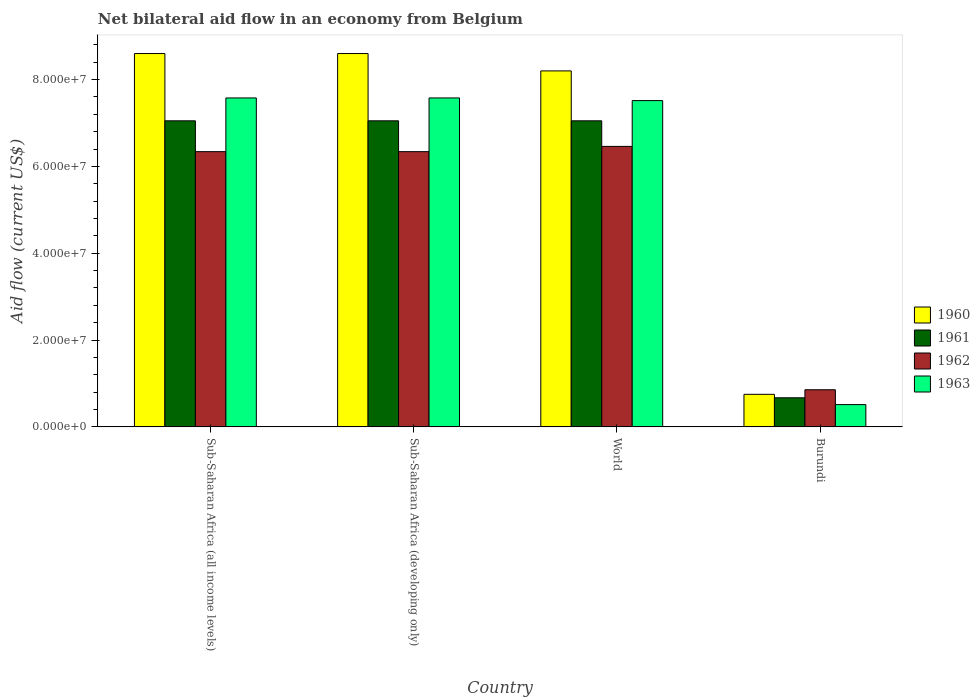How many different coloured bars are there?
Offer a terse response. 4. How many groups of bars are there?
Your response must be concise. 4. How many bars are there on the 1st tick from the left?
Your answer should be very brief. 4. What is the label of the 2nd group of bars from the left?
Provide a succinct answer. Sub-Saharan Africa (developing only). In how many cases, is the number of bars for a given country not equal to the number of legend labels?
Provide a short and direct response. 0. What is the net bilateral aid flow in 1960 in Sub-Saharan Africa (all income levels)?
Give a very brief answer. 8.60e+07. Across all countries, what is the maximum net bilateral aid flow in 1962?
Your response must be concise. 6.46e+07. Across all countries, what is the minimum net bilateral aid flow in 1962?
Offer a terse response. 8.55e+06. In which country was the net bilateral aid flow in 1961 minimum?
Offer a very short reply. Burundi. What is the total net bilateral aid flow in 1961 in the graph?
Provide a succinct answer. 2.18e+08. What is the difference between the net bilateral aid flow in 1963 in Burundi and that in Sub-Saharan Africa (developing only)?
Offer a terse response. -7.06e+07. What is the difference between the net bilateral aid flow in 1963 in Sub-Saharan Africa (all income levels) and the net bilateral aid flow in 1962 in World?
Offer a very short reply. 1.12e+07. What is the average net bilateral aid flow in 1962 per country?
Provide a succinct answer. 5.00e+07. What is the difference between the net bilateral aid flow of/in 1963 and net bilateral aid flow of/in 1961 in World?
Provide a succinct answer. 4.66e+06. In how many countries, is the net bilateral aid flow in 1960 greater than 16000000 US$?
Ensure brevity in your answer.  3. Is the net bilateral aid flow in 1962 in Burundi less than that in World?
Provide a succinct answer. Yes. Is the difference between the net bilateral aid flow in 1963 in Sub-Saharan Africa (all income levels) and Sub-Saharan Africa (developing only) greater than the difference between the net bilateral aid flow in 1961 in Sub-Saharan Africa (all income levels) and Sub-Saharan Africa (developing only)?
Provide a short and direct response. No. What is the difference between the highest and the second highest net bilateral aid flow in 1960?
Provide a succinct answer. 4.00e+06. What is the difference between the highest and the lowest net bilateral aid flow in 1962?
Your answer should be compact. 5.61e+07. In how many countries, is the net bilateral aid flow in 1961 greater than the average net bilateral aid flow in 1961 taken over all countries?
Offer a terse response. 3. Is the sum of the net bilateral aid flow in 1963 in Burundi and World greater than the maximum net bilateral aid flow in 1962 across all countries?
Offer a very short reply. Yes. Is it the case that in every country, the sum of the net bilateral aid flow in 1962 and net bilateral aid flow in 1960 is greater than the sum of net bilateral aid flow in 1963 and net bilateral aid flow in 1961?
Give a very brief answer. No. What does the 2nd bar from the right in World represents?
Give a very brief answer. 1962. Are all the bars in the graph horizontal?
Provide a short and direct response. No. How many countries are there in the graph?
Your response must be concise. 4. Where does the legend appear in the graph?
Provide a succinct answer. Center right. How many legend labels are there?
Your answer should be compact. 4. How are the legend labels stacked?
Your response must be concise. Vertical. What is the title of the graph?
Provide a succinct answer. Net bilateral aid flow in an economy from Belgium. What is the label or title of the Y-axis?
Give a very brief answer. Aid flow (current US$). What is the Aid flow (current US$) in 1960 in Sub-Saharan Africa (all income levels)?
Offer a terse response. 8.60e+07. What is the Aid flow (current US$) of 1961 in Sub-Saharan Africa (all income levels)?
Your response must be concise. 7.05e+07. What is the Aid flow (current US$) of 1962 in Sub-Saharan Africa (all income levels)?
Give a very brief answer. 6.34e+07. What is the Aid flow (current US$) of 1963 in Sub-Saharan Africa (all income levels)?
Ensure brevity in your answer.  7.58e+07. What is the Aid flow (current US$) in 1960 in Sub-Saharan Africa (developing only)?
Your answer should be compact. 8.60e+07. What is the Aid flow (current US$) in 1961 in Sub-Saharan Africa (developing only)?
Your answer should be compact. 7.05e+07. What is the Aid flow (current US$) in 1962 in Sub-Saharan Africa (developing only)?
Provide a short and direct response. 6.34e+07. What is the Aid flow (current US$) of 1963 in Sub-Saharan Africa (developing only)?
Offer a terse response. 7.58e+07. What is the Aid flow (current US$) in 1960 in World?
Make the answer very short. 8.20e+07. What is the Aid flow (current US$) in 1961 in World?
Your response must be concise. 7.05e+07. What is the Aid flow (current US$) of 1962 in World?
Keep it short and to the point. 6.46e+07. What is the Aid flow (current US$) of 1963 in World?
Your answer should be very brief. 7.52e+07. What is the Aid flow (current US$) of 1960 in Burundi?
Your answer should be very brief. 7.50e+06. What is the Aid flow (current US$) of 1961 in Burundi?
Ensure brevity in your answer.  6.70e+06. What is the Aid flow (current US$) of 1962 in Burundi?
Provide a succinct answer. 8.55e+06. What is the Aid flow (current US$) in 1963 in Burundi?
Ensure brevity in your answer.  5.13e+06. Across all countries, what is the maximum Aid flow (current US$) of 1960?
Make the answer very short. 8.60e+07. Across all countries, what is the maximum Aid flow (current US$) of 1961?
Offer a very short reply. 7.05e+07. Across all countries, what is the maximum Aid flow (current US$) of 1962?
Provide a succinct answer. 6.46e+07. Across all countries, what is the maximum Aid flow (current US$) of 1963?
Offer a very short reply. 7.58e+07. Across all countries, what is the minimum Aid flow (current US$) in 1960?
Provide a short and direct response. 7.50e+06. Across all countries, what is the minimum Aid flow (current US$) in 1961?
Your answer should be compact. 6.70e+06. Across all countries, what is the minimum Aid flow (current US$) in 1962?
Provide a short and direct response. 8.55e+06. Across all countries, what is the minimum Aid flow (current US$) in 1963?
Provide a succinct answer. 5.13e+06. What is the total Aid flow (current US$) in 1960 in the graph?
Your answer should be compact. 2.62e+08. What is the total Aid flow (current US$) of 1961 in the graph?
Your response must be concise. 2.18e+08. What is the total Aid flow (current US$) in 1962 in the graph?
Offer a very short reply. 2.00e+08. What is the total Aid flow (current US$) of 1963 in the graph?
Provide a short and direct response. 2.32e+08. What is the difference between the Aid flow (current US$) in 1960 in Sub-Saharan Africa (all income levels) and that in World?
Ensure brevity in your answer.  4.00e+06. What is the difference between the Aid flow (current US$) in 1962 in Sub-Saharan Africa (all income levels) and that in World?
Your answer should be very brief. -1.21e+06. What is the difference between the Aid flow (current US$) of 1963 in Sub-Saharan Africa (all income levels) and that in World?
Keep it short and to the point. 6.10e+05. What is the difference between the Aid flow (current US$) of 1960 in Sub-Saharan Africa (all income levels) and that in Burundi?
Provide a succinct answer. 7.85e+07. What is the difference between the Aid flow (current US$) of 1961 in Sub-Saharan Africa (all income levels) and that in Burundi?
Make the answer very short. 6.38e+07. What is the difference between the Aid flow (current US$) of 1962 in Sub-Saharan Africa (all income levels) and that in Burundi?
Your answer should be compact. 5.48e+07. What is the difference between the Aid flow (current US$) in 1963 in Sub-Saharan Africa (all income levels) and that in Burundi?
Ensure brevity in your answer.  7.06e+07. What is the difference between the Aid flow (current US$) of 1961 in Sub-Saharan Africa (developing only) and that in World?
Your answer should be very brief. 0. What is the difference between the Aid flow (current US$) of 1962 in Sub-Saharan Africa (developing only) and that in World?
Give a very brief answer. -1.21e+06. What is the difference between the Aid flow (current US$) of 1963 in Sub-Saharan Africa (developing only) and that in World?
Your response must be concise. 6.10e+05. What is the difference between the Aid flow (current US$) of 1960 in Sub-Saharan Africa (developing only) and that in Burundi?
Provide a short and direct response. 7.85e+07. What is the difference between the Aid flow (current US$) in 1961 in Sub-Saharan Africa (developing only) and that in Burundi?
Make the answer very short. 6.38e+07. What is the difference between the Aid flow (current US$) of 1962 in Sub-Saharan Africa (developing only) and that in Burundi?
Ensure brevity in your answer.  5.48e+07. What is the difference between the Aid flow (current US$) of 1963 in Sub-Saharan Africa (developing only) and that in Burundi?
Your response must be concise. 7.06e+07. What is the difference between the Aid flow (current US$) in 1960 in World and that in Burundi?
Your answer should be very brief. 7.45e+07. What is the difference between the Aid flow (current US$) of 1961 in World and that in Burundi?
Offer a terse response. 6.38e+07. What is the difference between the Aid flow (current US$) in 1962 in World and that in Burundi?
Offer a terse response. 5.61e+07. What is the difference between the Aid flow (current US$) of 1963 in World and that in Burundi?
Offer a very short reply. 7.00e+07. What is the difference between the Aid flow (current US$) of 1960 in Sub-Saharan Africa (all income levels) and the Aid flow (current US$) of 1961 in Sub-Saharan Africa (developing only)?
Offer a very short reply. 1.55e+07. What is the difference between the Aid flow (current US$) of 1960 in Sub-Saharan Africa (all income levels) and the Aid flow (current US$) of 1962 in Sub-Saharan Africa (developing only)?
Offer a terse response. 2.26e+07. What is the difference between the Aid flow (current US$) of 1960 in Sub-Saharan Africa (all income levels) and the Aid flow (current US$) of 1963 in Sub-Saharan Africa (developing only)?
Offer a very short reply. 1.02e+07. What is the difference between the Aid flow (current US$) of 1961 in Sub-Saharan Africa (all income levels) and the Aid flow (current US$) of 1962 in Sub-Saharan Africa (developing only)?
Your answer should be compact. 7.10e+06. What is the difference between the Aid flow (current US$) of 1961 in Sub-Saharan Africa (all income levels) and the Aid flow (current US$) of 1963 in Sub-Saharan Africa (developing only)?
Give a very brief answer. -5.27e+06. What is the difference between the Aid flow (current US$) in 1962 in Sub-Saharan Africa (all income levels) and the Aid flow (current US$) in 1963 in Sub-Saharan Africa (developing only)?
Your response must be concise. -1.24e+07. What is the difference between the Aid flow (current US$) in 1960 in Sub-Saharan Africa (all income levels) and the Aid flow (current US$) in 1961 in World?
Offer a very short reply. 1.55e+07. What is the difference between the Aid flow (current US$) of 1960 in Sub-Saharan Africa (all income levels) and the Aid flow (current US$) of 1962 in World?
Your response must be concise. 2.14e+07. What is the difference between the Aid flow (current US$) in 1960 in Sub-Saharan Africa (all income levels) and the Aid flow (current US$) in 1963 in World?
Provide a short and direct response. 1.08e+07. What is the difference between the Aid flow (current US$) in 1961 in Sub-Saharan Africa (all income levels) and the Aid flow (current US$) in 1962 in World?
Provide a succinct answer. 5.89e+06. What is the difference between the Aid flow (current US$) in 1961 in Sub-Saharan Africa (all income levels) and the Aid flow (current US$) in 1963 in World?
Your response must be concise. -4.66e+06. What is the difference between the Aid flow (current US$) of 1962 in Sub-Saharan Africa (all income levels) and the Aid flow (current US$) of 1963 in World?
Your answer should be compact. -1.18e+07. What is the difference between the Aid flow (current US$) of 1960 in Sub-Saharan Africa (all income levels) and the Aid flow (current US$) of 1961 in Burundi?
Ensure brevity in your answer.  7.93e+07. What is the difference between the Aid flow (current US$) of 1960 in Sub-Saharan Africa (all income levels) and the Aid flow (current US$) of 1962 in Burundi?
Give a very brief answer. 7.74e+07. What is the difference between the Aid flow (current US$) of 1960 in Sub-Saharan Africa (all income levels) and the Aid flow (current US$) of 1963 in Burundi?
Your answer should be very brief. 8.09e+07. What is the difference between the Aid flow (current US$) in 1961 in Sub-Saharan Africa (all income levels) and the Aid flow (current US$) in 1962 in Burundi?
Offer a very short reply. 6.20e+07. What is the difference between the Aid flow (current US$) of 1961 in Sub-Saharan Africa (all income levels) and the Aid flow (current US$) of 1963 in Burundi?
Ensure brevity in your answer.  6.54e+07. What is the difference between the Aid flow (current US$) of 1962 in Sub-Saharan Africa (all income levels) and the Aid flow (current US$) of 1963 in Burundi?
Make the answer very short. 5.83e+07. What is the difference between the Aid flow (current US$) in 1960 in Sub-Saharan Africa (developing only) and the Aid flow (current US$) in 1961 in World?
Your response must be concise. 1.55e+07. What is the difference between the Aid flow (current US$) in 1960 in Sub-Saharan Africa (developing only) and the Aid flow (current US$) in 1962 in World?
Offer a terse response. 2.14e+07. What is the difference between the Aid flow (current US$) in 1960 in Sub-Saharan Africa (developing only) and the Aid flow (current US$) in 1963 in World?
Your response must be concise. 1.08e+07. What is the difference between the Aid flow (current US$) of 1961 in Sub-Saharan Africa (developing only) and the Aid flow (current US$) of 1962 in World?
Ensure brevity in your answer.  5.89e+06. What is the difference between the Aid flow (current US$) in 1961 in Sub-Saharan Africa (developing only) and the Aid flow (current US$) in 1963 in World?
Give a very brief answer. -4.66e+06. What is the difference between the Aid flow (current US$) of 1962 in Sub-Saharan Africa (developing only) and the Aid flow (current US$) of 1963 in World?
Your answer should be very brief. -1.18e+07. What is the difference between the Aid flow (current US$) of 1960 in Sub-Saharan Africa (developing only) and the Aid flow (current US$) of 1961 in Burundi?
Your response must be concise. 7.93e+07. What is the difference between the Aid flow (current US$) in 1960 in Sub-Saharan Africa (developing only) and the Aid flow (current US$) in 1962 in Burundi?
Offer a terse response. 7.74e+07. What is the difference between the Aid flow (current US$) of 1960 in Sub-Saharan Africa (developing only) and the Aid flow (current US$) of 1963 in Burundi?
Offer a very short reply. 8.09e+07. What is the difference between the Aid flow (current US$) in 1961 in Sub-Saharan Africa (developing only) and the Aid flow (current US$) in 1962 in Burundi?
Give a very brief answer. 6.20e+07. What is the difference between the Aid flow (current US$) of 1961 in Sub-Saharan Africa (developing only) and the Aid flow (current US$) of 1963 in Burundi?
Offer a very short reply. 6.54e+07. What is the difference between the Aid flow (current US$) of 1962 in Sub-Saharan Africa (developing only) and the Aid flow (current US$) of 1963 in Burundi?
Keep it short and to the point. 5.83e+07. What is the difference between the Aid flow (current US$) in 1960 in World and the Aid flow (current US$) in 1961 in Burundi?
Offer a terse response. 7.53e+07. What is the difference between the Aid flow (current US$) of 1960 in World and the Aid flow (current US$) of 1962 in Burundi?
Your answer should be very brief. 7.34e+07. What is the difference between the Aid flow (current US$) of 1960 in World and the Aid flow (current US$) of 1963 in Burundi?
Provide a succinct answer. 7.69e+07. What is the difference between the Aid flow (current US$) in 1961 in World and the Aid flow (current US$) in 1962 in Burundi?
Your answer should be very brief. 6.20e+07. What is the difference between the Aid flow (current US$) of 1961 in World and the Aid flow (current US$) of 1963 in Burundi?
Offer a very short reply. 6.54e+07. What is the difference between the Aid flow (current US$) of 1962 in World and the Aid flow (current US$) of 1963 in Burundi?
Your answer should be very brief. 5.95e+07. What is the average Aid flow (current US$) of 1960 per country?
Offer a very short reply. 6.54e+07. What is the average Aid flow (current US$) of 1961 per country?
Offer a terse response. 5.46e+07. What is the average Aid flow (current US$) of 1962 per country?
Keep it short and to the point. 5.00e+07. What is the average Aid flow (current US$) in 1963 per country?
Ensure brevity in your answer.  5.80e+07. What is the difference between the Aid flow (current US$) in 1960 and Aid flow (current US$) in 1961 in Sub-Saharan Africa (all income levels)?
Give a very brief answer. 1.55e+07. What is the difference between the Aid flow (current US$) in 1960 and Aid flow (current US$) in 1962 in Sub-Saharan Africa (all income levels)?
Offer a terse response. 2.26e+07. What is the difference between the Aid flow (current US$) in 1960 and Aid flow (current US$) in 1963 in Sub-Saharan Africa (all income levels)?
Ensure brevity in your answer.  1.02e+07. What is the difference between the Aid flow (current US$) of 1961 and Aid flow (current US$) of 1962 in Sub-Saharan Africa (all income levels)?
Provide a succinct answer. 7.10e+06. What is the difference between the Aid flow (current US$) of 1961 and Aid flow (current US$) of 1963 in Sub-Saharan Africa (all income levels)?
Your answer should be very brief. -5.27e+06. What is the difference between the Aid flow (current US$) of 1962 and Aid flow (current US$) of 1963 in Sub-Saharan Africa (all income levels)?
Make the answer very short. -1.24e+07. What is the difference between the Aid flow (current US$) in 1960 and Aid flow (current US$) in 1961 in Sub-Saharan Africa (developing only)?
Provide a succinct answer. 1.55e+07. What is the difference between the Aid flow (current US$) of 1960 and Aid flow (current US$) of 1962 in Sub-Saharan Africa (developing only)?
Keep it short and to the point. 2.26e+07. What is the difference between the Aid flow (current US$) of 1960 and Aid flow (current US$) of 1963 in Sub-Saharan Africa (developing only)?
Your answer should be compact. 1.02e+07. What is the difference between the Aid flow (current US$) in 1961 and Aid flow (current US$) in 1962 in Sub-Saharan Africa (developing only)?
Provide a succinct answer. 7.10e+06. What is the difference between the Aid flow (current US$) in 1961 and Aid flow (current US$) in 1963 in Sub-Saharan Africa (developing only)?
Your response must be concise. -5.27e+06. What is the difference between the Aid flow (current US$) in 1962 and Aid flow (current US$) in 1963 in Sub-Saharan Africa (developing only)?
Offer a terse response. -1.24e+07. What is the difference between the Aid flow (current US$) in 1960 and Aid flow (current US$) in 1961 in World?
Provide a short and direct response. 1.15e+07. What is the difference between the Aid flow (current US$) in 1960 and Aid flow (current US$) in 1962 in World?
Give a very brief answer. 1.74e+07. What is the difference between the Aid flow (current US$) of 1960 and Aid flow (current US$) of 1963 in World?
Offer a very short reply. 6.84e+06. What is the difference between the Aid flow (current US$) in 1961 and Aid flow (current US$) in 1962 in World?
Give a very brief answer. 5.89e+06. What is the difference between the Aid flow (current US$) of 1961 and Aid flow (current US$) of 1963 in World?
Make the answer very short. -4.66e+06. What is the difference between the Aid flow (current US$) in 1962 and Aid flow (current US$) in 1963 in World?
Keep it short and to the point. -1.06e+07. What is the difference between the Aid flow (current US$) in 1960 and Aid flow (current US$) in 1961 in Burundi?
Your answer should be very brief. 8.00e+05. What is the difference between the Aid flow (current US$) of 1960 and Aid flow (current US$) of 1962 in Burundi?
Give a very brief answer. -1.05e+06. What is the difference between the Aid flow (current US$) of 1960 and Aid flow (current US$) of 1963 in Burundi?
Offer a very short reply. 2.37e+06. What is the difference between the Aid flow (current US$) of 1961 and Aid flow (current US$) of 1962 in Burundi?
Give a very brief answer. -1.85e+06. What is the difference between the Aid flow (current US$) in 1961 and Aid flow (current US$) in 1963 in Burundi?
Keep it short and to the point. 1.57e+06. What is the difference between the Aid flow (current US$) of 1962 and Aid flow (current US$) of 1963 in Burundi?
Your response must be concise. 3.42e+06. What is the ratio of the Aid flow (current US$) in 1961 in Sub-Saharan Africa (all income levels) to that in Sub-Saharan Africa (developing only)?
Your answer should be very brief. 1. What is the ratio of the Aid flow (current US$) in 1962 in Sub-Saharan Africa (all income levels) to that in Sub-Saharan Africa (developing only)?
Your response must be concise. 1. What is the ratio of the Aid flow (current US$) in 1960 in Sub-Saharan Africa (all income levels) to that in World?
Offer a terse response. 1.05. What is the ratio of the Aid flow (current US$) in 1961 in Sub-Saharan Africa (all income levels) to that in World?
Give a very brief answer. 1. What is the ratio of the Aid flow (current US$) of 1962 in Sub-Saharan Africa (all income levels) to that in World?
Provide a short and direct response. 0.98. What is the ratio of the Aid flow (current US$) of 1960 in Sub-Saharan Africa (all income levels) to that in Burundi?
Offer a very short reply. 11.47. What is the ratio of the Aid flow (current US$) in 1961 in Sub-Saharan Africa (all income levels) to that in Burundi?
Keep it short and to the point. 10.52. What is the ratio of the Aid flow (current US$) of 1962 in Sub-Saharan Africa (all income levels) to that in Burundi?
Offer a very short reply. 7.42. What is the ratio of the Aid flow (current US$) of 1963 in Sub-Saharan Africa (all income levels) to that in Burundi?
Keep it short and to the point. 14.77. What is the ratio of the Aid flow (current US$) of 1960 in Sub-Saharan Africa (developing only) to that in World?
Offer a terse response. 1.05. What is the ratio of the Aid flow (current US$) in 1962 in Sub-Saharan Africa (developing only) to that in World?
Provide a succinct answer. 0.98. What is the ratio of the Aid flow (current US$) of 1963 in Sub-Saharan Africa (developing only) to that in World?
Provide a succinct answer. 1.01. What is the ratio of the Aid flow (current US$) of 1960 in Sub-Saharan Africa (developing only) to that in Burundi?
Make the answer very short. 11.47. What is the ratio of the Aid flow (current US$) in 1961 in Sub-Saharan Africa (developing only) to that in Burundi?
Ensure brevity in your answer.  10.52. What is the ratio of the Aid flow (current US$) of 1962 in Sub-Saharan Africa (developing only) to that in Burundi?
Your answer should be very brief. 7.42. What is the ratio of the Aid flow (current US$) in 1963 in Sub-Saharan Africa (developing only) to that in Burundi?
Your answer should be compact. 14.77. What is the ratio of the Aid flow (current US$) in 1960 in World to that in Burundi?
Provide a short and direct response. 10.93. What is the ratio of the Aid flow (current US$) of 1961 in World to that in Burundi?
Make the answer very short. 10.52. What is the ratio of the Aid flow (current US$) of 1962 in World to that in Burundi?
Your response must be concise. 7.56. What is the ratio of the Aid flow (current US$) of 1963 in World to that in Burundi?
Keep it short and to the point. 14.65. What is the difference between the highest and the second highest Aid flow (current US$) of 1960?
Offer a very short reply. 0. What is the difference between the highest and the second highest Aid flow (current US$) in 1962?
Ensure brevity in your answer.  1.21e+06. What is the difference between the highest and the lowest Aid flow (current US$) in 1960?
Your answer should be compact. 7.85e+07. What is the difference between the highest and the lowest Aid flow (current US$) of 1961?
Your answer should be very brief. 6.38e+07. What is the difference between the highest and the lowest Aid flow (current US$) of 1962?
Ensure brevity in your answer.  5.61e+07. What is the difference between the highest and the lowest Aid flow (current US$) of 1963?
Offer a very short reply. 7.06e+07. 